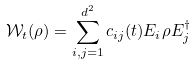<formula> <loc_0><loc_0><loc_500><loc_500>\mathcal { W } _ { t } ( \rho ) = \sum _ { i , j = 1 } ^ { d ^ { 2 } } c _ { i j } ( t ) E _ { i } \rho E _ { j } ^ { \dag }</formula> 